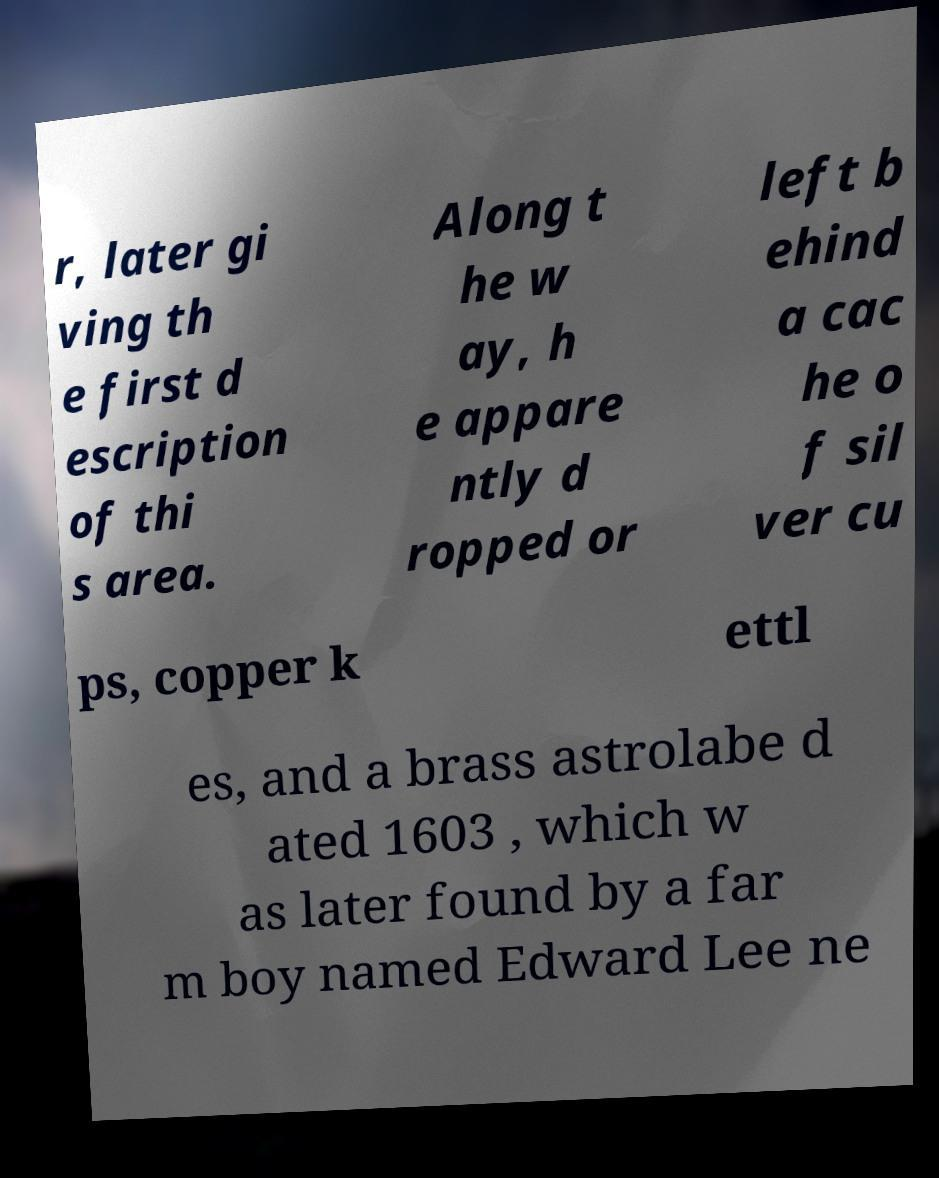Can you accurately transcribe the text from the provided image for me? r, later gi ving th e first d escription of thi s area. Along t he w ay, h e appare ntly d ropped or left b ehind a cac he o f sil ver cu ps, copper k ettl es, and a brass astrolabe d ated 1603 , which w as later found by a far m boy named Edward Lee ne 